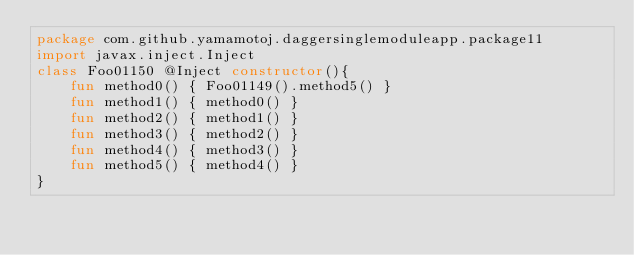<code> <loc_0><loc_0><loc_500><loc_500><_Kotlin_>package com.github.yamamotoj.daggersinglemoduleapp.package11
import javax.inject.Inject
class Foo01150 @Inject constructor(){
    fun method0() { Foo01149().method5() }
    fun method1() { method0() }
    fun method2() { method1() }
    fun method3() { method2() }
    fun method4() { method3() }
    fun method5() { method4() }
}
</code> 